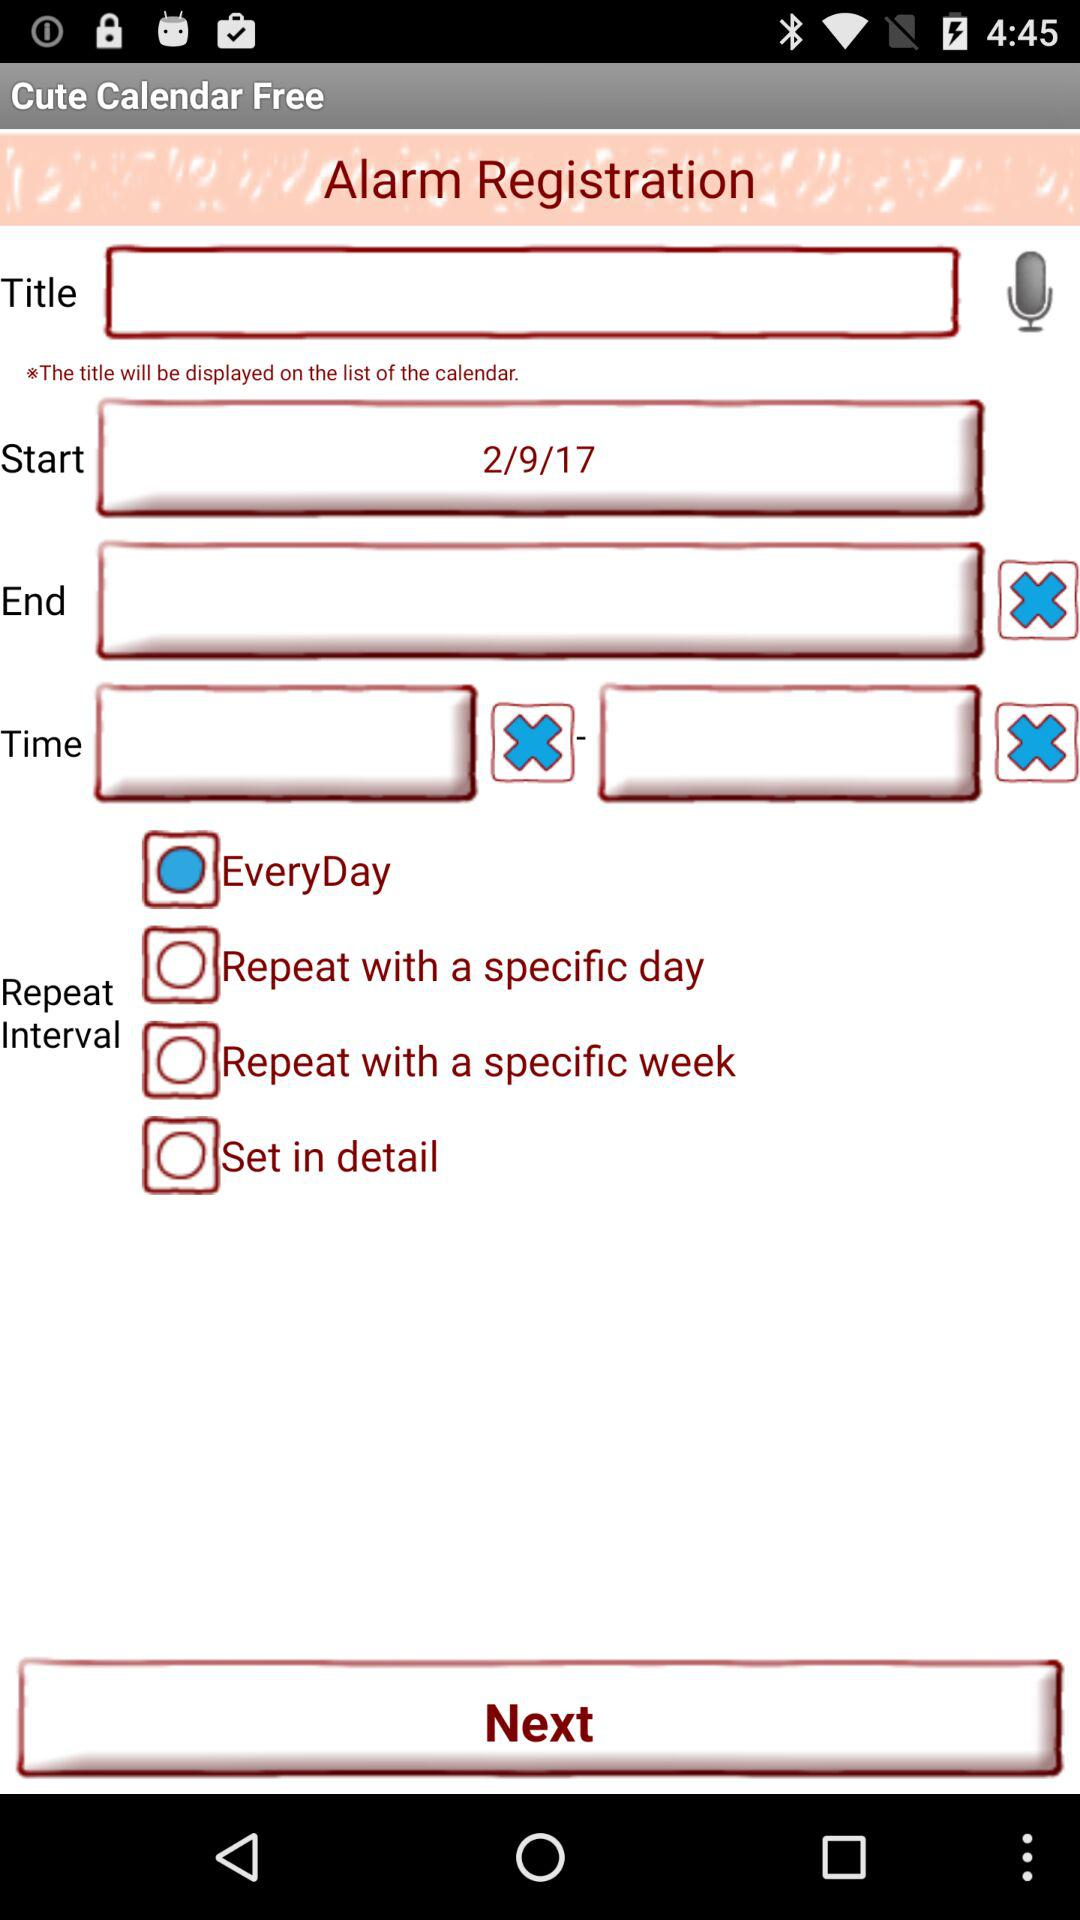What is the current status of the "EveryDay"? The status is on. 